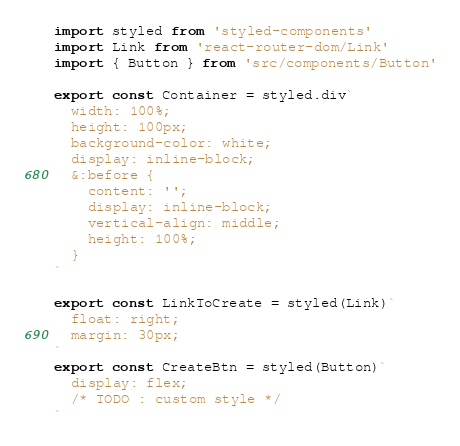Convert code to text. <code><loc_0><loc_0><loc_500><loc_500><_JavaScript_>import styled from 'styled-components'
import Link from 'react-router-dom/Link'
import { Button } from 'src/components/Button'

export const Container = styled.div`
  width: 100%;
  height: 100px;
  background-color: white;
  display: inline-block;
  &:before {
    content: '';
    display: inline-block;
    vertical-align: middle;
    height: 100%;
  }
`

export const LinkToCreate = styled(Link)`
  float: right;
  margin: 30px;
`
export const CreateBtn = styled(Button)`
  display: flex;
  /* TODO : custom style */
`
</code> 